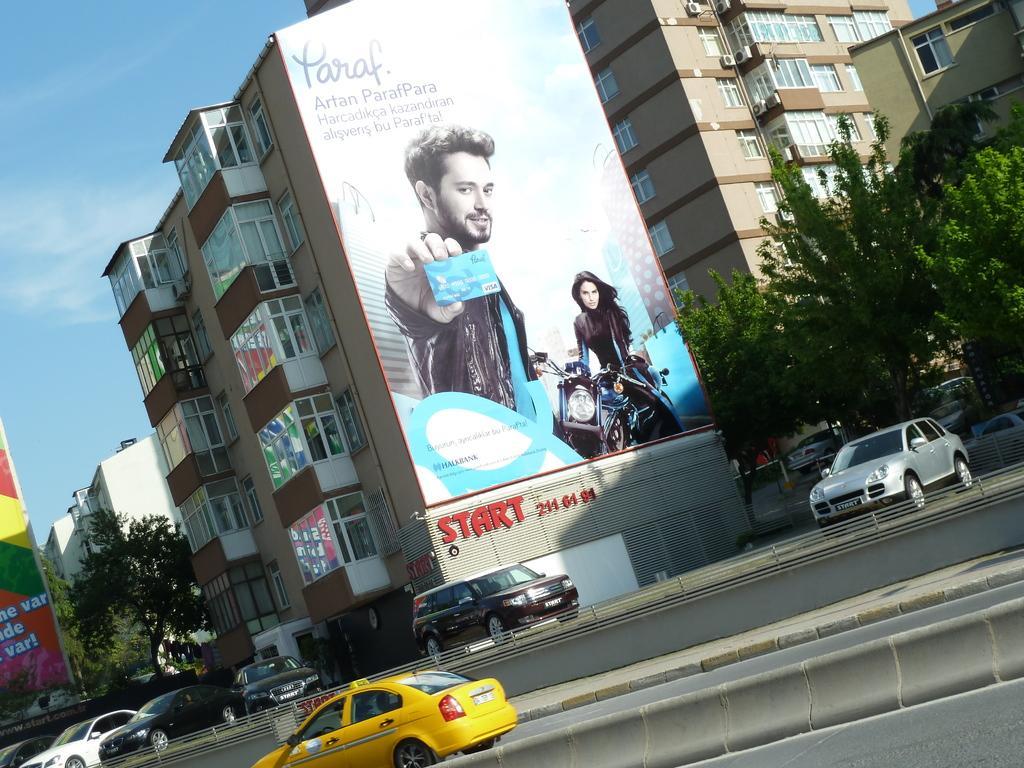Please provide a concise description of this image. In this image i can see few vehicles trees and building. In the background i can see sky, there is a huge banners in the building. 